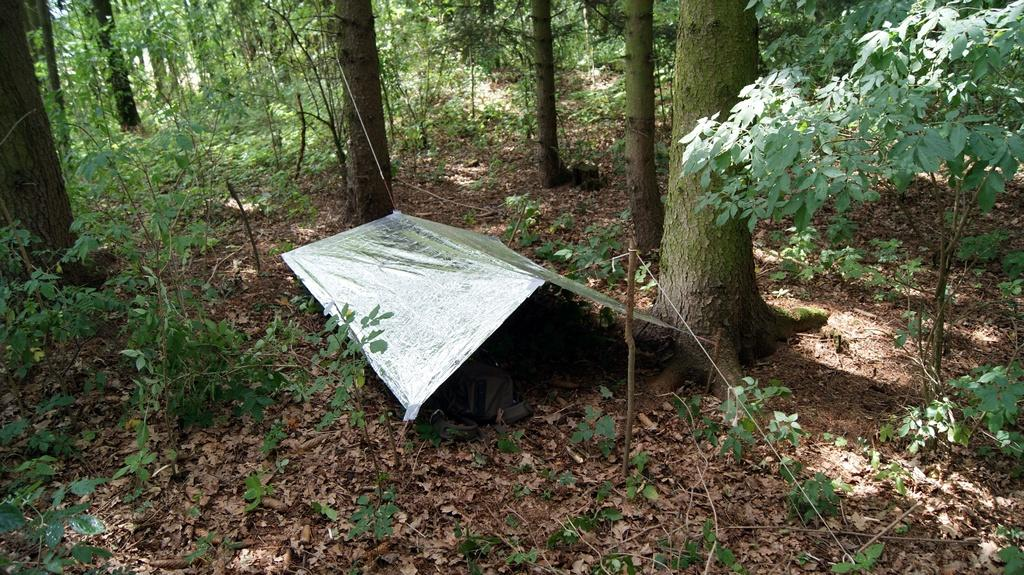What type of shelter is visible in the image? There is a small tent in the image. Where is the tent located? The tent is on the land. What type of vegetation can be seen in the image? There are plants and trees in the image. How many legs can be seen on the robin in the image? There is no robin present in the image. 